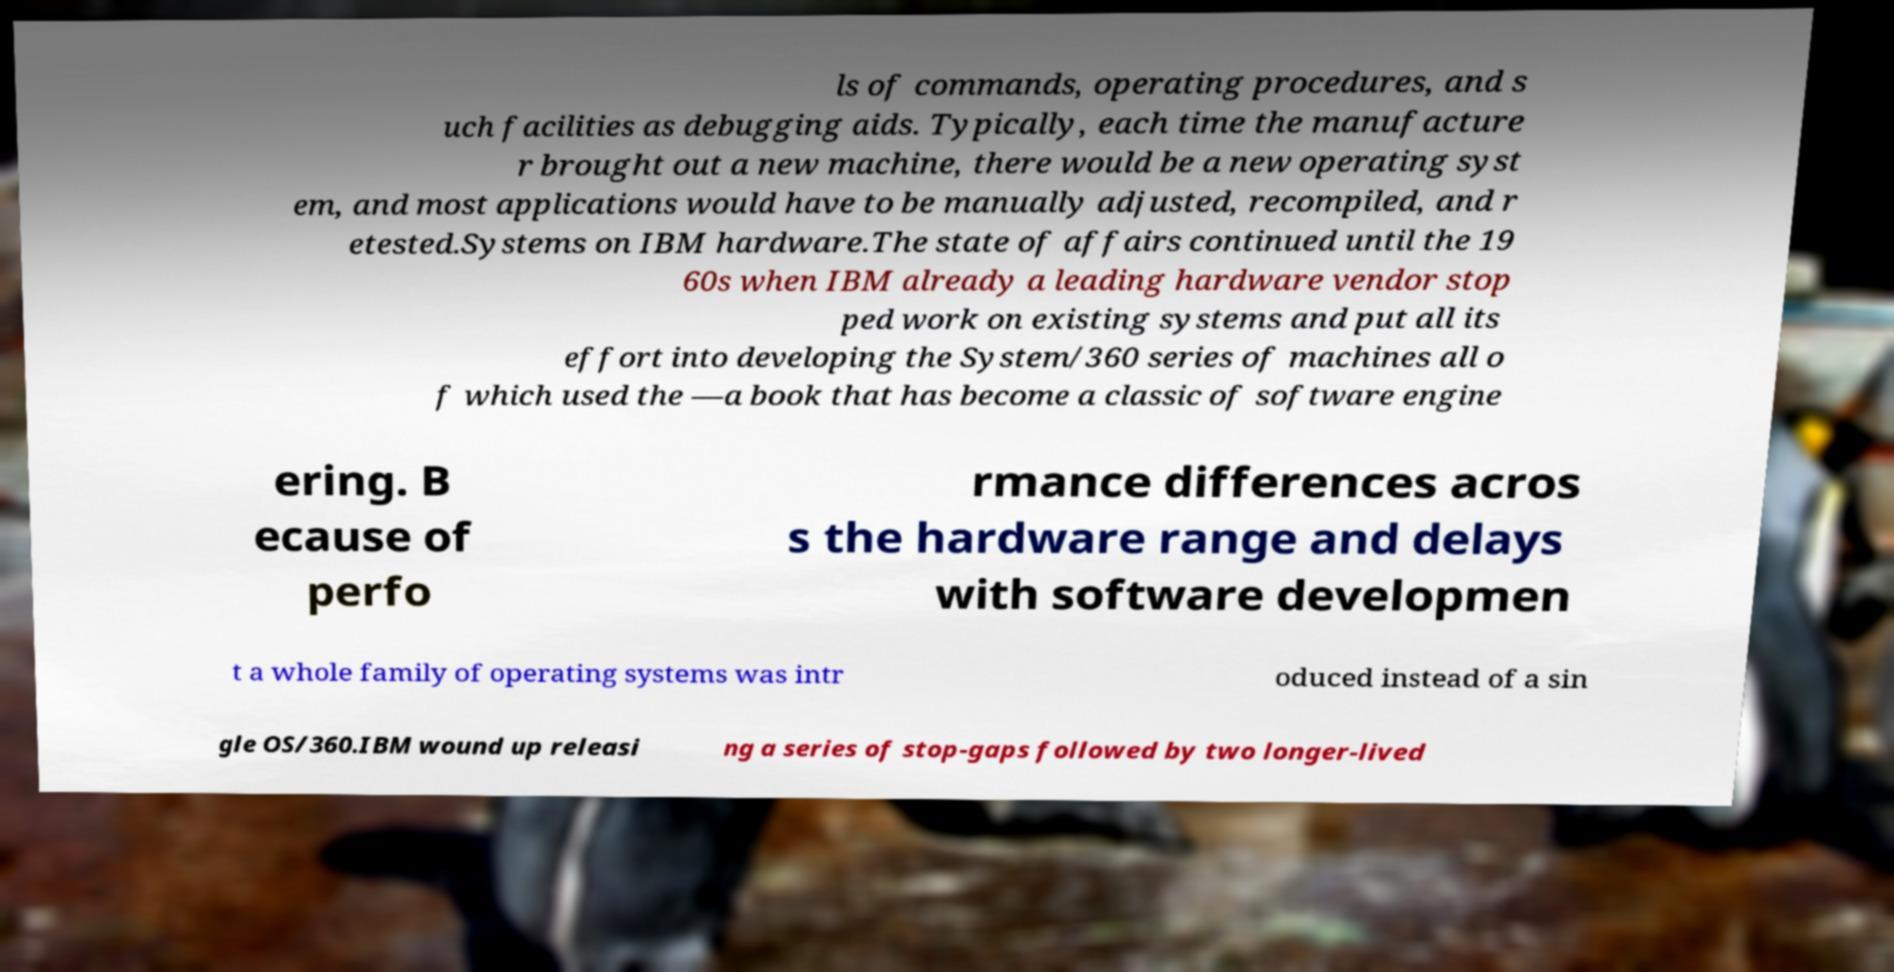There's text embedded in this image that I need extracted. Can you transcribe it verbatim? ls of commands, operating procedures, and s uch facilities as debugging aids. Typically, each time the manufacture r brought out a new machine, there would be a new operating syst em, and most applications would have to be manually adjusted, recompiled, and r etested.Systems on IBM hardware.The state of affairs continued until the 19 60s when IBM already a leading hardware vendor stop ped work on existing systems and put all its effort into developing the System/360 series of machines all o f which used the —a book that has become a classic of software engine ering. B ecause of perfo rmance differences acros s the hardware range and delays with software developmen t a whole family of operating systems was intr oduced instead of a sin gle OS/360.IBM wound up releasi ng a series of stop-gaps followed by two longer-lived 